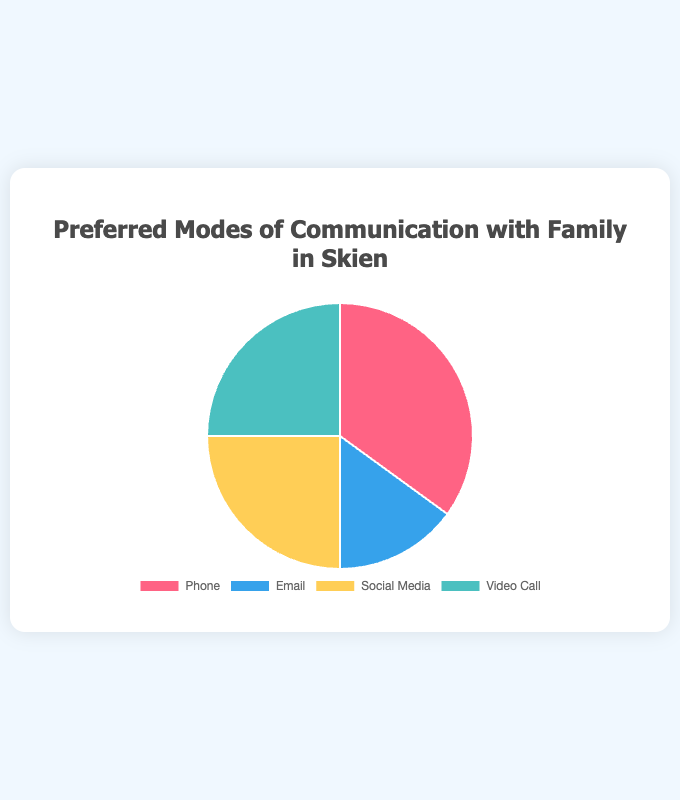What's the most preferred mode of communication with family in Skien? The largest section of the pie chart represents Phone at 35%, which is the highest among all the modes of communication displayed.
Answer: Phone Which modes of communication share the same preference percentage? By examining the pie chart, Social Media and Video Call each occupy 25%, indicating they share the same preference.
Answer: Social Media and Video Call What is the total percentage of people preferring Social Media or Video Call? The percentages for Social Media and Video Call are both 25%. Adding these together, 25% + 25% = 50%.
Answer: 50% Is Email a less preferred mode of communication than Social Media? The pie chart shows that Email occupies 15%, while Social Media occupies 25%. Hence, Email is less preferred than Social Media.
Answer: Yes Which color represents the most preferred mode of communication? The chart legend indicates that the color representing Phone (most preferred mode with 35%) is red.
Answer: Red What is the difference in percentage between the most preferred and least preferred modes of communication? The most preferred mode (Phone) is 35% and the least preferred mode (Email) is 15%. The difference is 35% - 15% = 20%.
Answer: 20% If 200 people were surveyed, how many prefer Video Calls? Video Call preference is 25%. Therefore, 25% of 200 is (25/100) * 200 = 50 people.
Answer: 50 Are there more people who prefer Phone than the combined total of those who prefer Email and Social Media? Phone is preferred by 35%. Email and Social Media combined are 15% + 25% = 40%. Therefore, more people prefer Email and Social Media combined than Phone.
Answer: No If you combine the percentages of Social Media and Phone preferences, what fraction of the total does it constitute? Social Media is 25% and Phone is 35%. Their combined percentage is 60%. 60% is 60 out of 100, which is simplified as 3/5.
Answer: 3/5 